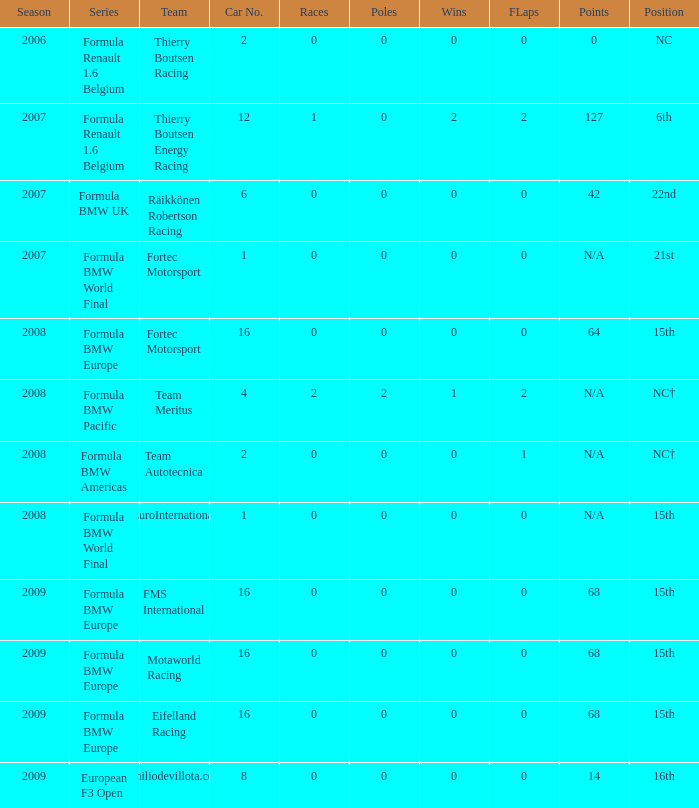Name the points for car number 4 N/A. 